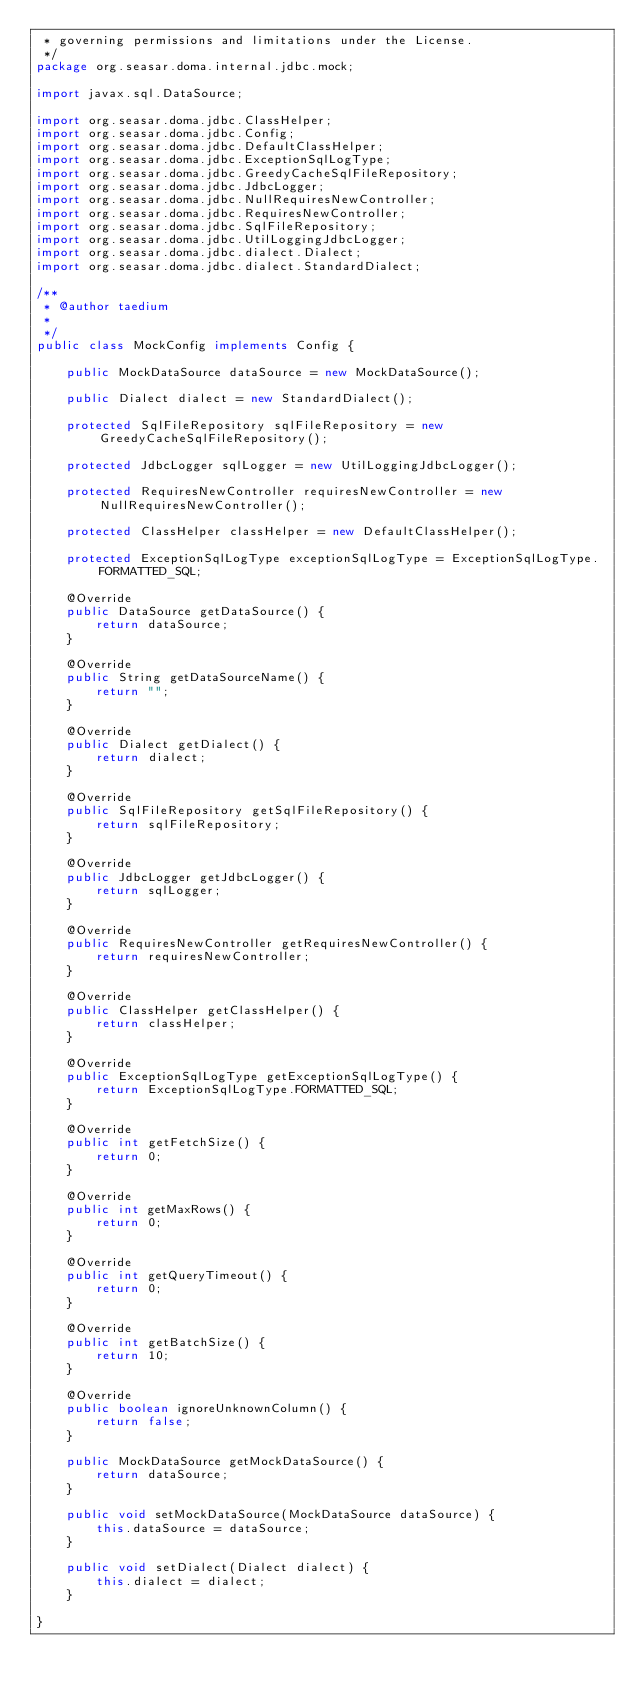Convert code to text. <code><loc_0><loc_0><loc_500><loc_500><_Java_> * governing permissions and limitations under the License.
 */
package org.seasar.doma.internal.jdbc.mock;

import javax.sql.DataSource;

import org.seasar.doma.jdbc.ClassHelper;
import org.seasar.doma.jdbc.Config;
import org.seasar.doma.jdbc.DefaultClassHelper;
import org.seasar.doma.jdbc.ExceptionSqlLogType;
import org.seasar.doma.jdbc.GreedyCacheSqlFileRepository;
import org.seasar.doma.jdbc.JdbcLogger;
import org.seasar.doma.jdbc.NullRequiresNewController;
import org.seasar.doma.jdbc.RequiresNewController;
import org.seasar.doma.jdbc.SqlFileRepository;
import org.seasar.doma.jdbc.UtilLoggingJdbcLogger;
import org.seasar.doma.jdbc.dialect.Dialect;
import org.seasar.doma.jdbc.dialect.StandardDialect;

/**
 * @author taedium
 * 
 */
public class MockConfig implements Config {

    public MockDataSource dataSource = new MockDataSource();

    public Dialect dialect = new StandardDialect();

    protected SqlFileRepository sqlFileRepository = new GreedyCacheSqlFileRepository();

    protected JdbcLogger sqlLogger = new UtilLoggingJdbcLogger();

    protected RequiresNewController requiresNewController = new NullRequiresNewController();

    protected ClassHelper classHelper = new DefaultClassHelper();

    protected ExceptionSqlLogType exceptionSqlLogType = ExceptionSqlLogType.FORMATTED_SQL;

    @Override
    public DataSource getDataSource() {
        return dataSource;
    }

    @Override
    public String getDataSourceName() {
        return "";
    }

    @Override
    public Dialect getDialect() {
        return dialect;
    }

    @Override
    public SqlFileRepository getSqlFileRepository() {
        return sqlFileRepository;
    }

    @Override
    public JdbcLogger getJdbcLogger() {
        return sqlLogger;
    }

    @Override
    public RequiresNewController getRequiresNewController() {
        return requiresNewController;
    }

    @Override
    public ClassHelper getClassHelper() {
        return classHelper;
    }

    @Override
    public ExceptionSqlLogType getExceptionSqlLogType() {
        return ExceptionSqlLogType.FORMATTED_SQL;
    }

    @Override
    public int getFetchSize() {
        return 0;
    }

    @Override
    public int getMaxRows() {
        return 0;
    }

    @Override
    public int getQueryTimeout() {
        return 0;
    }

    @Override
    public int getBatchSize() {
        return 10;
    }

    @Override
    public boolean ignoreUnknownColumn() {
        return false;
    }

    public MockDataSource getMockDataSource() {
        return dataSource;
    }

    public void setMockDataSource(MockDataSource dataSource) {
        this.dataSource = dataSource;
    }

    public void setDialect(Dialect dialect) {
        this.dialect = dialect;
    }

}
</code> 